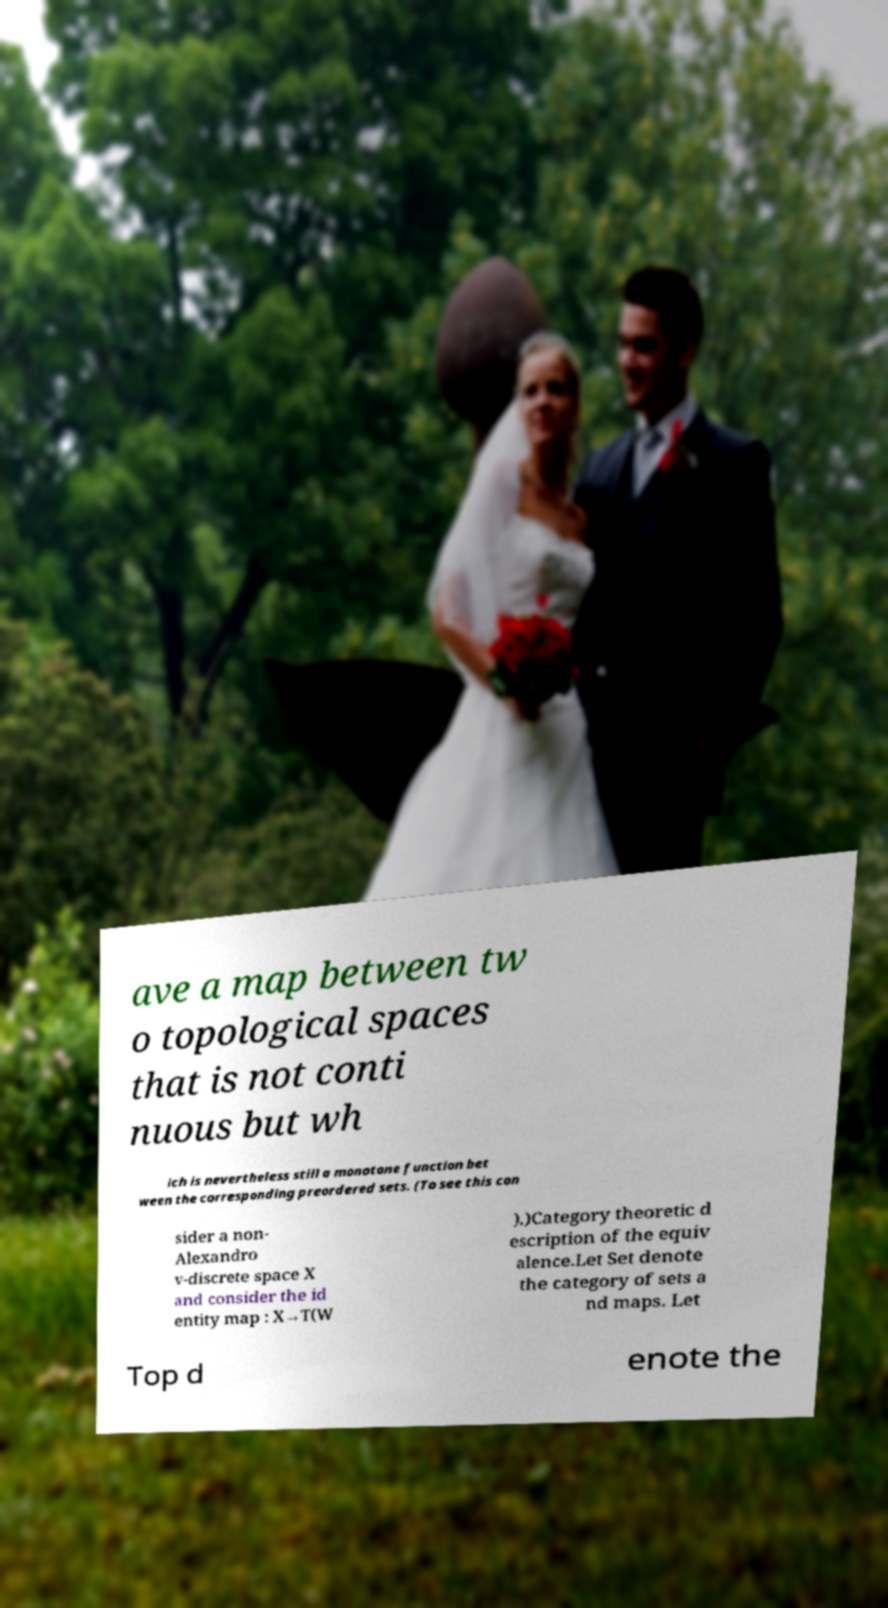Can you read and provide the text displayed in the image?This photo seems to have some interesting text. Can you extract and type it out for me? ave a map between tw o topological spaces that is not conti nuous but wh ich is nevertheless still a monotone function bet ween the corresponding preordered sets. (To see this con sider a non- Alexandro v-discrete space X and consider the id entity map : X→T(W ).)Category theoretic d escription of the equiv alence.Let Set denote the category of sets a nd maps. Let Top d enote the 